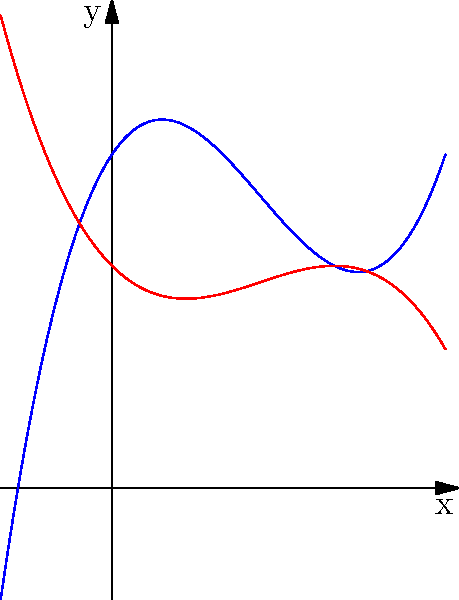The graph above shows the cross-sectional profiles of two golf club heads: a driver (blue) and an iron (red), represented by polynomial functions. Which club head has a larger sweet spot (the area where the club face is most effective) based on the width of the curve at its peak? To determine which club head has a larger sweet spot, we need to compare the width of the curves at their peaks. A wider curve at the peak indicates a larger sweet spot. Let's analyze each curve:

1. Driver (blue curve):
   - The curve is represented by a cubic function.
   - It has a wider, more rounded peak.
   - The peak occurs around $x=2$.
   - The curve is relatively flat near its peak, creating a broad area.

2. Iron (red curve):
   - This curve is also represented by a cubic function.
   - It has a narrower, more pointed peak.
   - The peak occurs around $x=1.5$.
   - The curve changes direction more sharply near its peak, creating a smaller area.

Comparing the two:
- The driver's curve (blue) is noticeably wider at its peak than the iron's curve (red).
- The flatter top of the driver's curve indicates a larger area where the club face is most effective.
- The iron's curve, being more pointed, suggests a smaller area of optimal contact.

Therefore, based on the width of the curve at its peak, the driver (blue curve) has a larger sweet spot compared to the iron.
Answer: Driver (blue curve) 